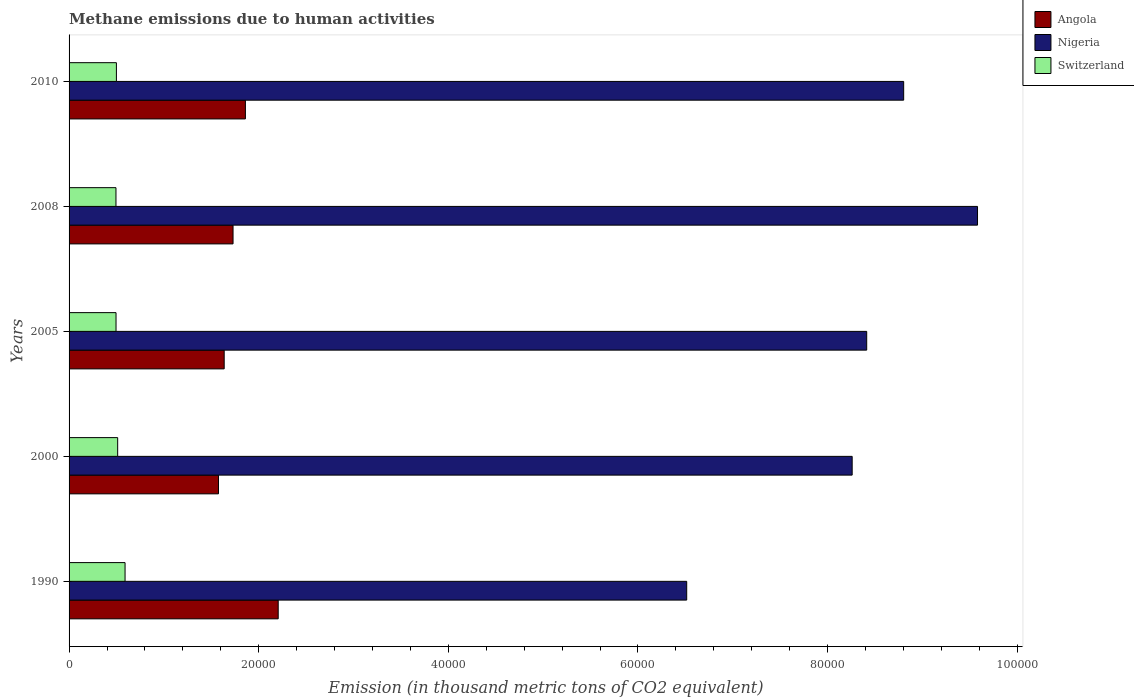How many different coloured bars are there?
Make the answer very short. 3. What is the amount of methane emitted in Angola in 2008?
Provide a short and direct response. 1.73e+04. Across all years, what is the maximum amount of methane emitted in Nigeria?
Provide a succinct answer. 9.58e+04. Across all years, what is the minimum amount of methane emitted in Nigeria?
Provide a short and direct response. 6.51e+04. What is the total amount of methane emitted in Angola in the graph?
Your response must be concise. 9.01e+04. What is the difference between the amount of methane emitted in Switzerland in 2005 and that in 2010?
Your answer should be compact. -39. What is the difference between the amount of methane emitted in Switzerland in 1990 and the amount of methane emitted in Nigeria in 2005?
Make the answer very short. -7.82e+04. What is the average amount of methane emitted in Nigeria per year?
Make the answer very short. 8.31e+04. In the year 2005, what is the difference between the amount of methane emitted in Nigeria and amount of methane emitted in Angola?
Your response must be concise. 6.78e+04. What is the ratio of the amount of methane emitted in Switzerland in 2000 to that in 2005?
Your answer should be very brief. 1.03. Is the amount of methane emitted in Switzerland in 2000 less than that in 2010?
Offer a very short reply. No. Is the difference between the amount of methane emitted in Nigeria in 2000 and 2008 greater than the difference between the amount of methane emitted in Angola in 2000 and 2008?
Offer a very short reply. No. What is the difference between the highest and the second highest amount of methane emitted in Switzerland?
Offer a terse response. 778.6. What is the difference between the highest and the lowest amount of methane emitted in Angola?
Your answer should be compact. 6298. What does the 3rd bar from the top in 2010 represents?
Make the answer very short. Angola. What does the 3rd bar from the bottom in 2008 represents?
Your answer should be very brief. Switzerland. Is it the case that in every year, the sum of the amount of methane emitted in Nigeria and amount of methane emitted in Angola is greater than the amount of methane emitted in Switzerland?
Offer a very short reply. Yes. Are all the bars in the graph horizontal?
Your answer should be compact. Yes. What is the difference between two consecutive major ticks on the X-axis?
Keep it short and to the point. 2.00e+04. Are the values on the major ticks of X-axis written in scientific E-notation?
Give a very brief answer. No. Does the graph contain any zero values?
Your response must be concise. No. How many legend labels are there?
Your answer should be compact. 3. What is the title of the graph?
Give a very brief answer. Methane emissions due to human activities. Does "Korea (Republic)" appear as one of the legend labels in the graph?
Your answer should be compact. No. What is the label or title of the X-axis?
Give a very brief answer. Emission (in thousand metric tons of CO2 equivalent). What is the Emission (in thousand metric tons of CO2 equivalent) in Angola in 1990?
Offer a very short reply. 2.21e+04. What is the Emission (in thousand metric tons of CO2 equivalent) of Nigeria in 1990?
Offer a very short reply. 6.51e+04. What is the Emission (in thousand metric tons of CO2 equivalent) of Switzerland in 1990?
Make the answer very short. 5904.8. What is the Emission (in thousand metric tons of CO2 equivalent) in Angola in 2000?
Provide a succinct answer. 1.58e+04. What is the Emission (in thousand metric tons of CO2 equivalent) of Nigeria in 2000?
Your answer should be very brief. 8.26e+04. What is the Emission (in thousand metric tons of CO2 equivalent) in Switzerland in 2000?
Offer a very short reply. 5126.2. What is the Emission (in thousand metric tons of CO2 equivalent) in Angola in 2005?
Provide a succinct answer. 1.64e+04. What is the Emission (in thousand metric tons of CO2 equivalent) of Nigeria in 2005?
Ensure brevity in your answer.  8.41e+04. What is the Emission (in thousand metric tons of CO2 equivalent) in Switzerland in 2005?
Keep it short and to the point. 4953.4. What is the Emission (in thousand metric tons of CO2 equivalent) of Angola in 2008?
Your response must be concise. 1.73e+04. What is the Emission (in thousand metric tons of CO2 equivalent) in Nigeria in 2008?
Ensure brevity in your answer.  9.58e+04. What is the Emission (in thousand metric tons of CO2 equivalent) of Switzerland in 2008?
Provide a succinct answer. 4946.1. What is the Emission (in thousand metric tons of CO2 equivalent) in Angola in 2010?
Offer a terse response. 1.86e+04. What is the Emission (in thousand metric tons of CO2 equivalent) in Nigeria in 2010?
Keep it short and to the point. 8.80e+04. What is the Emission (in thousand metric tons of CO2 equivalent) in Switzerland in 2010?
Provide a short and direct response. 4992.4. Across all years, what is the maximum Emission (in thousand metric tons of CO2 equivalent) in Angola?
Ensure brevity in your answer.  2.21e+04. Across all years, what is the maximum Emission (in thousand metric tons of CO2 equivalent) of Nigeria?
Provide a succinct answer. 9.58e+04. Across all years, what is the maximum Emission (in thousand metric tons of CO2 equivalent) of Switzerland?
Your answer should be compact. 5904.8. Across all years, what is the minimum Emission (in thousand metric tons of CO2 equivalent) in Angola?
Give a very brief answer. 1.58e+04. Across all years, what is the minimum Emission (in thousand metric tons of CO2 equivalent) in Nigeria?
Your answer should be very brief. 6.51e+04. Across all years, what is the minimum Emission (in thousand metric tons of CO2 equivalent) in Switzerland?
Ensure brevity in your answer.  4946.1. What is the total Emission (in thousand metric tons of CO2 equivalent) in Angola in the graph?
Offer a very short reply. 9.01e+04. What is the total Emission (in thousand metric tons of CO2 equivalent) of Nigeria in the graph?
Ensure brevity in your answer.  4.16e+05. What is the total Emission (in thousand metric tons of CO2 equivalent) of Switzerland in the graph?
Keep it short and to the point. 2.59e+04. What is the difference between the Emission (in thousand metric tons of CO2 equivalent) of Angola in 1990 and that in 2000?
Offer a terse response. 6298. What is the difference between the Emission (in thousand metric tons of CO2 equivalent) in Nigeria in 1990 and that in 2000?
Provide a short and direct response. -1.75e+04. What is the difference between the Emission (in thousand metric tons of CO2 equivalent) in Switzerland in 1990 and that in 2000?
Ensure brevity in your answer.  778.6. What is the difference between the Emission (in thousand metric tons of CO2 equivalent) in Angola in 1990 and that in 2005?
Your answer should be very brief. 5697.9. What is the difference between the Emission (in thousand metric tons of CO2 equivalent) in Nigeria in 1990 and that in 2005?
Ensure brevity in your answer.  -1.90e+04. What is the difference between the Emission (in thousand metric tons of CO2 equivalent) of Switzerland in 1990 and that in 2005?
Offer a very short reply. 951.4. What is the difference between the Emission (in thousand metric tons of CO2 equivalent) of Angola in 1990 and that in 2008?
Make the answer very short. 4763.8. What is the difference between the Emission (in thousand metric tons of CO2 equivalent) in Nigeria in 1990 and that in 2008?
Your answer should be compact. -3.07e+04. What is the difference between the Emission (in thousand metric tons of CO2 equivalent) in Switzerland in 1990 and that in 2008?
Ensure brevity in your answer.  958.7. What is the difference between the Emission (in thousand metric tons of CO2 equivalent) in Angola in 1990 and that in 2010?
Ensure brevity in your answer.  3460.1. What is the difference between the Emission (in thousand metric tons of CO2 equivalent) of Nigeria in 1990 and that in 2010?
Give a very brief answer. -2.29e+04. What is the difference between the Emission (in thousand metric tons of CO2 equivalent) in Switzerland in 1990 and that in 2010?
Ensure brevity in your answer.  912.4. What is the difference between the Emission (in thousand metric tons of CO2 equivalent) in Angola in 2000 and that in 2005?
Ensure brevity in your answer.  -600.1. What is the difference between the Emission (in thousand metric tons of CO2 equivalent) in Nigeria in 2000 and that in 2005?
Give a very brief answer. -1533.6. What is the difference between the Emission (in thousand metric tons of CO2 equivalent) of Switzerland in 2000 and that in 2005?
Provide a short and direct response. 172.8. What is the difference between the Emission (in thousand metric tons of CO2 equivalent) in Angola in 2000 and that in 2008?
Offer a terse response. -1534.2. What is the difference between the Emission (in thousand metric tons of CO2 equivalent) in Nigeria in 2000 and that in 2008?
Offer a very short reply. -1.32e+04. What is the difference between the Emission (in thousand metric tons of CO2 equivalent) in Switzerland in 2000 and that in 2008?
Give a very brief answer. 180.1. What is the difference between the Emission (in thousand metric tons of CO2 equivalent) in Angola in 2000 and that in 2010?
Your response must be concise. -2837.9. What is the difference between the Emission (in thousand metric tons of CO2 equivalent) in Nigeria in 2000 and that in 2010?
Your response must be concise. -5432.6. What is the difference between the Emission (in thousand metric tons of CO2 equivalent) of Switzerland in 2000 and that in 2010?
Your response must be concise. 133.8. What is the difference between the Emission (in thousand metric tons of CO2 equivalent) in Angola in 2005 and that in 2008?
Provide a succinct answer. -934.1. What is the difference between the Emission (in thousand metric tons of CO2 equivalent) of Nigeria in 2005 and that in 2008?
Ensure brevity in your answer.  -1.17e+04. What is the difference between the Emission (in thousand metric tons of CO2 equivalent) in Angola in 2005 and that in 2010?
Offer a very short reply. -2237.8. What is the difference between the Emission (in thousand metric tons of CO2 equivalent) of Nigeria in 2005 and that in 2010?
Make the answer very short. -3899. What is the difference between the Emission (in thousand metric tons of CO2 equivalent) in Switzerland in 2005 and that in 2010?
Provide a succinct answer. -39. What is the difference between the Emission (in thousand metric tons of CO2 equivalent) of Angola in 2008 and that in 2010?
Keep it short and to the point. -1303.7. What is the difference between the Emission (in thousand metric tons of CO2 equivalent) of Nigeria in 2008 and that in 2010?
Offer a very short reply. 7786.3. What is the difference between the Emission (in thousand metric tons of CO2 equivalent) of Switzerland in 2008 and that in 2010?
Keep it short and to the point. -46.3. What is the difference between the Emission (in thousand metric tons of CO2 equivalent) of Angola in 1990 and the Emission (in thousand metric tons of CO2 equivalent) of Nigeria in 2000?
Your response must be concise. -6.05e+04. What is the difference between the Emission (in thousand metric tons of CO2 equivalent) of Angola in 1990 and the Emission (in thousand metric tons of CO2 equivalent) of Switzerland in 2000?
Ensure brevity in your answer.  1.69e+04. What is the difference between the Emission (in thousand metric tons of CO2 equivalent) in Nigeria in 1990 and the Emission (in thousand metric tons of CO2 equivalent) in Switzerland in 2000?
Provide a short and direct response. 6.00e+04. What is the difference between the Emission (in thousand metric tons of CO2 equivalent) of Angola in 1990 and the Emission (in thousand metric tons of CO2 equivalent) of Nigeria in 2005?
Provide a short and direct response. -6.21e+04. What is the difference between the Emission (in thousand metric tons of CO2 equivalent) of Angola in 1990 and the Emission (in thousand metric tons of CO2 equivalent) of Switzerland in 2005?
Your response must be concise. 1.71e+04. What is the difference between the Emission (in thousand metric tons of CO2 equivalent) of Nigeria in 1990 and the Emission (in thousand metric tons of CO2 equivalent) of Switzerland in 2005?
Give a very brief answer. 6.02e+04. What is the difference between the Emission (in thousand metric tons of CO2 equivalent) of Angola in 1990 and the Emission (in thousand metric tons of CO2 equivalent) of Nigeria in 2008?
Make the answer very short. -7.38e+04. What is the difference between the Emission (in thousand metric tons of CO2 equivalent) in Angola in 1990 and the Emission (in thousand metric tons of CO2 equivalent) in Switzerland in 2008?
Offer a very short reply. 1.71e+04. What is the difference between the Emission (in thousand metric tons of CO2 equivalent) of Nigeria in 1990 and the Emission (in thousand metric tons of CO2 equivalent) of Switzerland in 2008?
Offer a terse response. 6.02e+04. What is the difference between the Emission (in thousand metric tons of CO2 equivalent) of Angola in 1990 and the Emission (in thousand metric tons of CO2 equivalent) of Nigeria in 2010?
Offer a very short reply. -6.60e+04. What is the difference between the Emission (in thousand metric tons of CO2 equivalent) of Angola in 1990 and the Emission (in thousand metric tons of CO2 equivalent) of Switzerland in 2010?
Ensure brevity in your answer.  1.71e+04. What is the difference between the Emission (in thousand metric tons of CO2 equivalent) of Nigeria in 1990 and the Emission (in thousand metric tons of CO2 equivalent) of Switzerland in 2010?
Your response must be concise. 6.01e+04. What is the difference between the Emission (in thousand metric tons of CO2 equivalent) in Angola in 2000 and the Emission (in thousand metric tons of CO2 equivalent) in Nigeria in 2005?
Your response must be concise. -6.84e+04. What is the difference between the Emission (in thousand metric tons of CO2 equivalent) of Angola in 2000 and the Emission (in thousand metric tons of CO2 equivalent) of Switzerland in 2005?
Provide a short and direct response. 1.08e+04. What is the difference between the Emission (in thousand metric tons of CO2 equivalent) in Nigeria in 2000 and the Emission (in thousand metric tons of CO2 equivalent) in Switzerland in 2005?
Make the answer very short. 7.76e+04. What is the difference between the Emission (in thousand metric tons of CO2 equivalent) of Angola in 2000 and the Emission (in thousand metric tons of CO2 equivalent) of Nigeria in 2008?
Your answer should be compact. -8.00e+04. What is the difference between the Emission (in thousand metric tons of CO2 equivalent) in Angola in 2000 and the Emission (in thousand metric tons of CO2 equivalent) in Switzerland in 2008?
Make the answer very short. 1.08e+04. What is the difference between the Emission (in thousand metric tons of CO2 equivalent) in Nigeria in 2000 and the Emission (in thousand metric tons of CO2 equivalent) in Switzerland in 2008?
Make the answer very short. 7.76e+04. What is the difference between the Emission (in thousand metric tons of CO2 equivalent) of Angola in 2000 and the Emission (in thousand metric tons of CO2 equivalent) of Nigeria in 2010?
Make the answer very short. -7.23e+04. What is the difference between the Emission (in thousand metric tons of CO2 equivalent) of Angola in 2000 and the Emission (in thousand metric tons of CO2 equivalent) of Switzerland in 2010?
Offer a very short reply. 1.08e+04. What is the difference between the Emission (in thousand metric tons of CO2 equivalent) of Nigeria in 2000 and the Emission (in thousand metric tons of CO2 equivalent) of Switzerland in 2010?
Offer a terse response. 7.76e+04. What is the difference between the Emission (in thousand metric tons of CO2 equivalent) in Angola in 2005 and the Emission (in thousand metric tons of CO2 equivalent) in Nigeria in 2008?
Provide a succinct answer. -7.94e+04. What is the difference between the Emission (in thousand metric tons of CO2 equivalent) of Angola in 2005 and the Emission (in thousand metric tons of CO2 equivalent) of Switzerland in 2008?
Your response must be concise. 1.14e+04. What is the difference between the Emission (in thousand metric tons of CO2 equivalent) in Nigeria in 2005 and the Emission (in thousand metric tons of CO2 equivalent) in Switzerland in 2008?
Provide a succinct answer. 7.92e+04. What is the difference between the Emission (in thousand metric tons of CO2 equivalent) in Angola in 2005 and the Emission (in thousand metric tons of CO2 equivalent) in Nigeria in 2010?
Provide a short and direct response. -7.17e+04. What is the difference between the Emission (in thousand metric tons of CO2 equivalent) in Angola in 2005 and the Emission (in thousand metric tons of CO2 equivalent) in Switzerland in 2010?
Provide a short and direct response. 1.14e+04. What is the difference between the Emission (in thousand metric tons of CO2 equivalent) in Nigeria in 2005 and the Emission (in thousand metric tons of CO2 equivalent) in Switzerland in 2010?
Ensure brevity in your answer.  7.91e+04. What is the difference between the Emission (in thousand metric tons of CO2 equivalent) in Angola in 2008 and the Emission (in thousand metric tons of CO2 equivalent) in Nigeria in 2010?
Give a very brief answer. -7.07e+04. What is the difference between the Emission (in thousand metric tons of CO2 equivalent) in Angola in 2008 and the Emission (in thousand metric tons of CO2 equivalent) in Switzerland in 2010?
Provide a succinct answer. 1.23e+04. What is the difference between the Emission (in thousand metric tons of CO2 equivalent) of Nigeria in 2008 and the Emission (in thousand metric tons of CO2 equivalent) of Switzerland in 2010?
Keep it short and to the point. 9.08e+04. What is the average Emission (in thousand metric tons of CO2 equivalent) of Angola per year?
Provide a short and direct response. 1.80e+04. What is the average Emission (in thousand metric tons of CO2 equivalent) in Nigeria per year?
Your response must be concise. 8.31e+04. What is the average Emission (in thousand metric tons of CO2 equivalent) in Switzerland per year?
Provide a short and direct response. 5184.58. In the year 1990, what is the difference between the Emission (in thousand metric tons of CO2 equivalent) in Angola and Emission (in thousand metric tons of CO2 equivalent) in Nigeria?
Ensure brevity in your answer.  -4.31e+04. In the year 1990, what is the difference between the Emission (in thousand metric tons of CO2 equivalent) of Angola and Emission (in thousand metric tons of CO2 equivalent) of Switzerland?
Provide a short and direct response. 1.62e+04. In the year 1990, what is the difference between the Emission (in thousand metric tons of CO2 equivalent) of Nigeria and Emission (in thousand metric tons of CO2 equivalent) of Switzerland?
Ensure brevity in your answer.  5.92e+04. In the year 2000, what is the difference between the Emission (in thousand metric tons of CO2 equivalent) of Angola and Emission (in thousand metric tons of CO2 equivalent) of Nigeria?
Your answer should be very brief. -6.68e+04. In the year 2000, what is the difference between the Emission (in thousand metric tons of CO2 equivalent) in Angola and Emission (in thousand metric tons of CO2 equivalent) in Switzerland?
Your answer should be very brief. 1.06e+04. In the year 2000, what is the difference between the Emission (in thousand metric tons of CO2 equivalent) in Nigeria and Emission (in thousand metric tons of CO2 equivalent) in Switzerland?
Make the answer very short. 7.75e+04. In the year 2005, what is the difference between the Emission (in thousand metric tons of CO2 equivalent) in Angola and Emission (in thousand metric tons of CO2 equivalent) in Nigeria?
Ensure brevity in your answer.  -6.78e+04. In the year 2005, what is the difference between the Emission (in thousand metric tons of CO2 equivalent) of Angola and Emission (in thousand metric tons of CO2 equivalent) of Switzerland?
Your answer should be compact. 1.14e+04. In the year 2005, what is the difference between the Emission (in thousand metric tons of CO2 equivalent) of Nigeria and Emission (in thousand metric tons of CO2 equivalent) of Switzerland?
Ensure brevity in your answer.  7.92e+04. In the year 2008, what is the difference between the Emission (in thousand metric tons of CO2 equivalent) in Angola and Emission (in thousand metric tons of CO2 equivalent) in Nigeria?
Provide a succinct answer. -7.85e+04. In the year 2008, what is the difference between the Emission (in thousand metric tons of CO2 equivalent) of Angola and Emission (in thousand metric tons of CO2 equivalent) of Switzerland?
Give a very brief answer. 1.23e+04. In the year 2008, what is the difference between the Emission (in thousand metric tons of CO2 equivalent) of Nigeria and Emission (in thousand metric tons of CO2 equivalent) of Switzerland?
Make the answer very short. 9.09e+04. In the year 2010, what is the difference between the Emission (in thousand metric tons of CO2 equivalent) in Angola and Emission (in thousand metric tons of CO2 equivalent) in Nigeria?
Provide a succinct answer. -6.94e+04. In the year 2010, what is the difference between the Emission (in thousand metric tons of CO2 equivalent) of Angola and Emission (in thousand metric tons of CO2 equivalent) of Switzerland?
Your response must be concise. 1.36e+04. In the year 2010, what is the difference between the Emission (in thousand metric tons of CO2 equivalent) in Nigeria and Emission (in thousand metric tons of CO2 equivalent) in Switzerland?
Your answer should be very brief. 8.30e+04. What is the ratio of the Emission (in thousand metric tons of CO2 equivalent) of Angola in 1990 to that in 2000?
Keep it short and to the point. 1.4. What is the ratio of the Emission (in thousand metric tons of CO2 equivalent) of Nigeria in 1990 to that in 2000?
Offer a terse response. 0.79. What is the ratio of the Emission (in thousand metric tons of CO2 equivalent) of Switzerland in 1990 to that in 2000?
Your answer should be compact. 1.15. What is the ratio of the Emission (in thousand metric tons of CO2 equivalent) of Angola in 1990 to that in 2005?
Offer a very short reply. 1.35. What is the ratio of the Emission (in thousand metric tons of CO2 equivalent) of Nigeria in 1990 to that in 2005?
Make the answer very short. 0.77. What is the ratio of the Emission (in thousand metric tons of CO2 equivalent) in Switzerland in 1990 to that in 2005?
Offer a very short reply. 1.19. What is the ratio of the Emission (in thousand metric tons of CO2 equivalent) in Angola in 1990 to that in 2008?
Offer a very short reply. 1.28. What is the ratio of the Emission (in thousand metric tons of CO2 equivalent) of Nigeria in 1990 to that in 2008?
Offer a terse response. 0.68. What is the ratio of the Emission (in thousand metric tons of CO2 equivalent) of Switzerland in 1990 to that in 2008?
Ensure brevity in your answer.  1.19. What is the ratio of the Emission (in thousand metric tons of CO2 equivalent) of Angola in 1990 to that in 2010?
Ensure brevity in your answer.  1.19. What is the ratio of the Emission (in thousand metric tons of CO2 equivalent) of Nigeria in 1990 to that in 2010?
Keep it short and to the point. 0.74. What is the ratio of the Emission (in thousand metric tons of CO2 equivalent) in Switzerland in 1990 to that in 2010?
Provide a succinct answer. 1.18. What is the ratio of the Emission (in thousand metric tons of CO2 equivalent) of Angola in 2000 to that in 2005?
Offer a very short reply. 0.96. What is the ratio of the Emission (in thousand metric tons of CO2 equivalent) of Nigeria in 2000 to that in 2005?
Offer a very short reply. 0.98. What is the ratio of the Emission (in thousand metric tons of CO2 equivalent) of Switzerland in 2000 to that in 2005?
Provide a succinct answer. 1.03. What is the ratio of the Emission (in thousand metric tons of CO2 equivalent) of Angola in 2000 to that in 2008?
Offer a very short reply. 0.91. What is the ratio of the Emission (in thousand metric tons of CO2 equivalent) of Nigeria in 2000 to that in 2008?
Your response must be concise. 0.86. What is the ratio of the Emission (in thousand metric tons of CO2 equivalent) in Switzerland in 2000 to that in 2008?
Your answer should be compact. 1.04. What is the ratio of the Emission (in thousand metric tons of CO2 equivalent) in Angola in 2000 to that in 2010?
Your response must be concise. 0.85. What is the ratio of the Emission (in thousand metric tons of CO2 equivalent) in Nigeria in 2000 to that in 2010?
Offer a very short reply. 0.94. What is the ratio of the Emission (in thousand metric tons of CO2 equivalent) in Switzerland in 2000 to that in 2010?
Provide a short and direct response. 1.03. What is the ratio of the Emission (in thousand metric tons of CO2 equivalent) of Angola in 2005 to that in 2008?
Make the answer very short. 0.95. What is the ratio of the Emission (in thousand metric tons of CO2 equivalent) of Nigeria in 2005 to that in 2008?
Give a very brief answer. 0.88. What is the ratio of the Emission (in thousand metric tons of CO2 equivalent) of Angola in 2005 to that in 2010?
Your response must be concise. 0.88. What is the ratio of the Emission (in thousand metric tons of CO2 equivalent) of Nigeria in 2005 to that in 2010?
Offer a terse response. 0.96. What is the ratio of the Emission (in thousand metric tons of CO2 equivalent) of Angola in 2008 to that in 2010?
Keep it short and to the point. 0.93. What is the ratio of the Emission (in thousand metric tons of CO2 equivalent) of Nigeria in 2008 to that in 2010?
Give a very brief answer. 1.09. What is the ratio of the Emission (in thousand metric tons of CO2 equivalent) in Switzerland in 2008 to that in 2010?
Provide a succinct answer. 0.99. What is the difference between the highest and the second highest Emission (in thousand metric tons of CO2 equivalent) of Angola?
Keep it short and to the point. 3460.1. What is the difference between the highest and the second highest Emission (in thousand metric tons of CO2 equivalent) in Nigeria?
Ensure brevity in your answer.  7786.3. What is the difference between the highest and the second highest Emission (in thousand metric tons of CO2 equivalent) of Switzerland?
Provide a succinct answer. 778.6. What is the difference between the highest and the lowest Emission (in thousand metric tons of CO2 equivalent) in Angola?
Your response must be concise. 6298. What is the difference between the highest and the lowest Emission (in thousand metric tons of CO2 equivalent) of Nigeria?
Your response must be concise. 3.07e+04. What is the difference between the highest and the lowest Emission (in thousand metric tons of CO2 equivalent) of Switzerland?
Your answer should be compact. 958.7. 